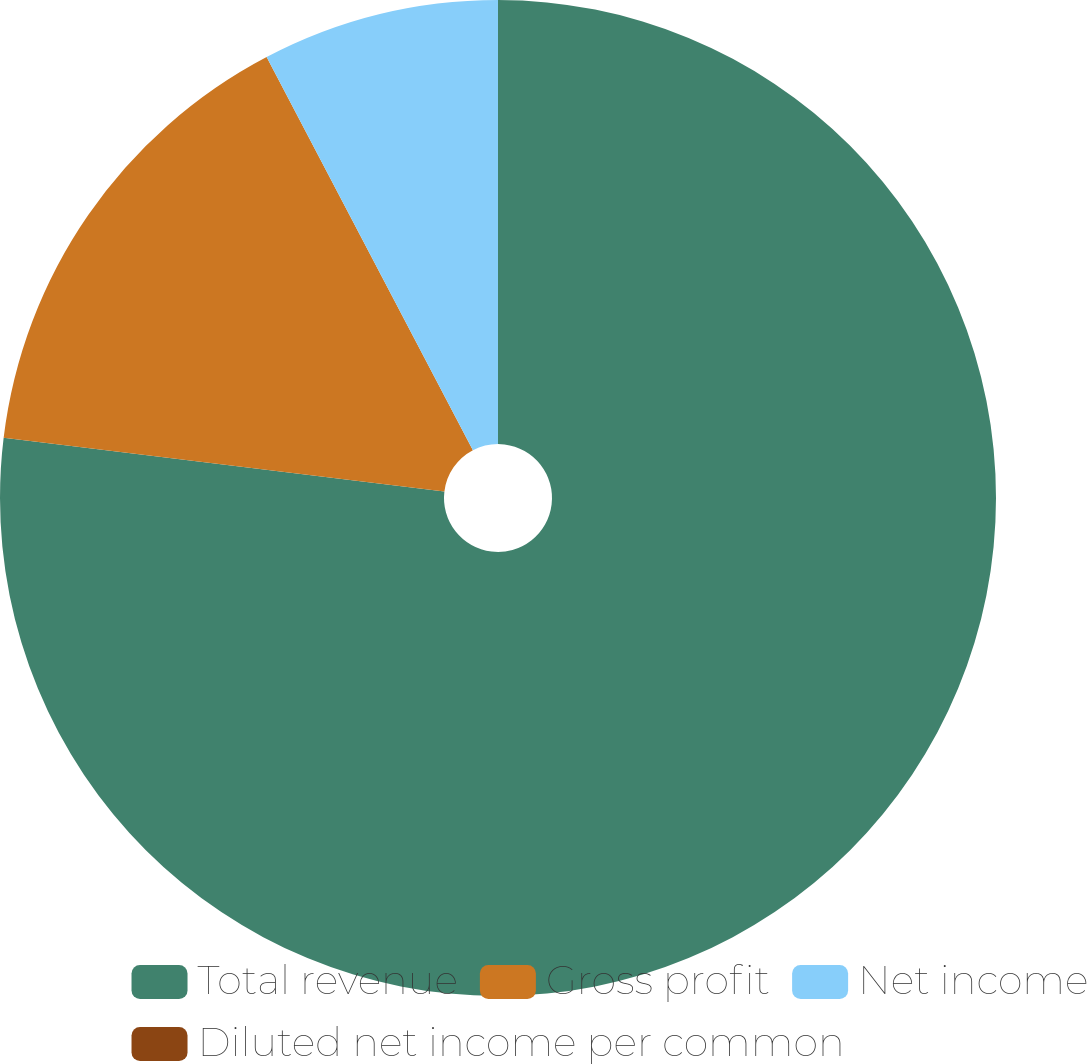<chart> <loc_0><loc_0><loc_500><loc_500><pie_chart><fcel>Total revenue<fcel>Gross profit<fcel>Net income<fcel>Diluted net income per common<nl><fcel>76.92%<fcel>15.38%<fcel>7.69%<fcel>0.0%<nl></chart> 